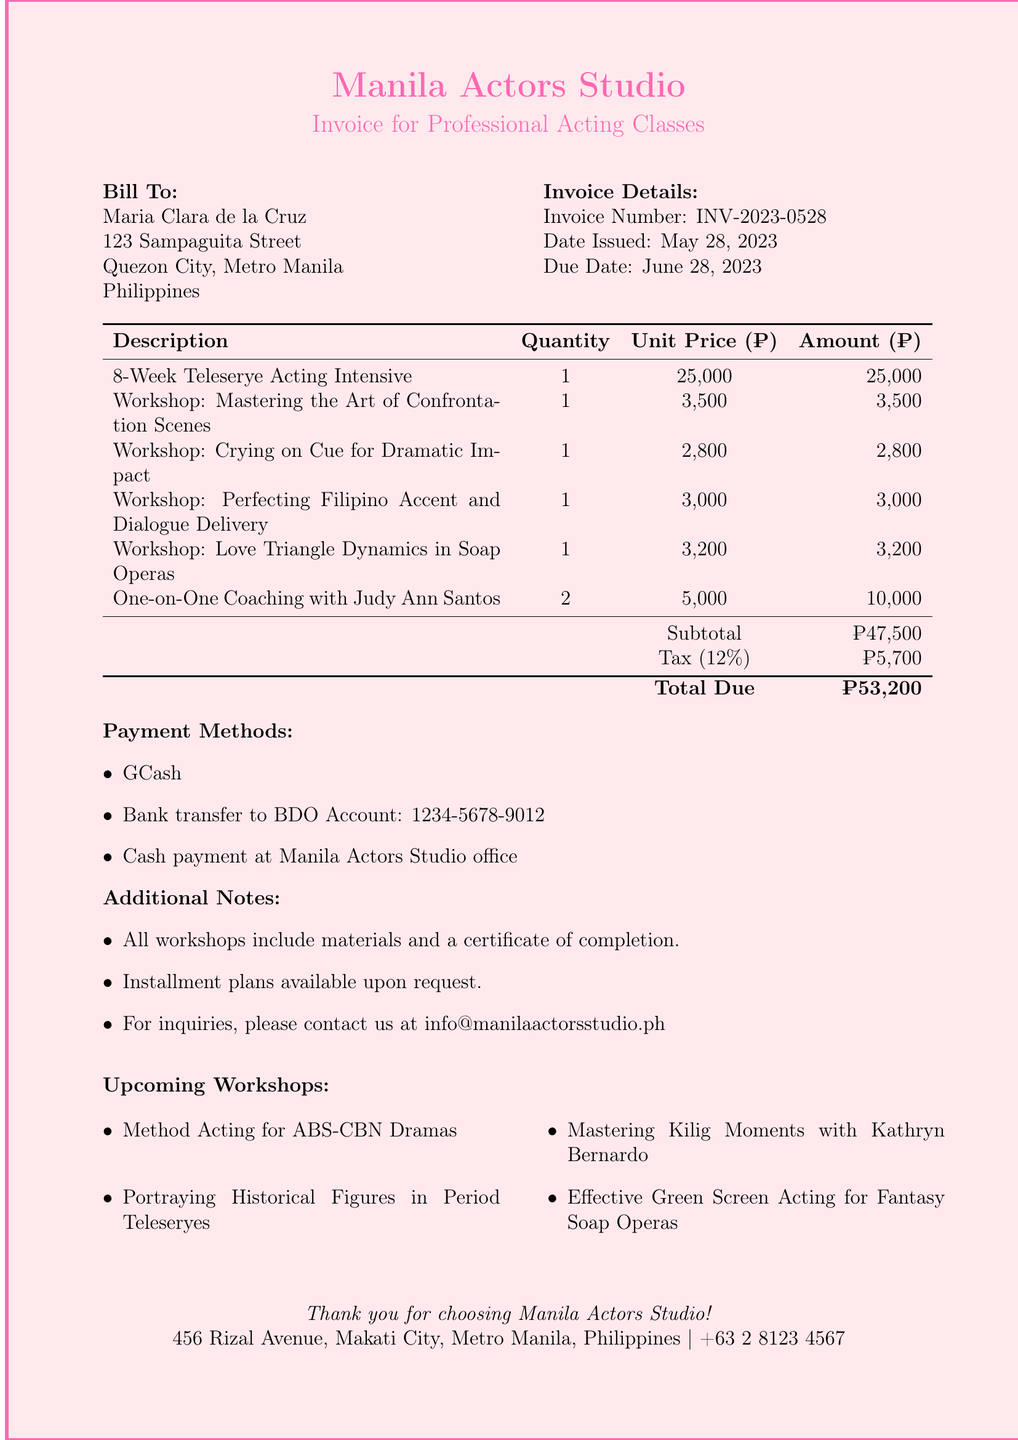What is the invoice number? The invoice number is explicitly stated in the document under Invoice Details.
Answer: INV-2023-0528 What is the date issued? The date issued is mentioned in the document, which is part of the Invoice Details.
Answer: May 28, 2023 What is the total amount due? The total amount due is provided at the bottom of the itemized services table.
Answer: ₱53,200 What payment methods are listed? The payment methods are detailed in a specific section of the invoice.
Answer: GCash, Bank transfer to BDO Account: 1234-5678-9012, Cash payment at Manila Actors Studio office How many workshops are included in the invoice? The total number of workshops can be calculated by counting the items in the itemized services list.
Answer: 5 What workshop focuses on confrontation scenes? This information is found under the itemized services provided in the document.
Answer: Mastering the Art of Confrontation Scenes What is the tax rate applied to the invoice? The tax rate is mentioned in the subtotal and tax sections of the document.
Answer: 12% How many one-on-one coaching sessions are included? The quantity of one-on-one coaching sessions is specified in the itemized services table.
Answer: 2 Which workshop is aimed at perfecting Filipino accent? This workshop is stated in the list of itemized services in the invoice.
Answer: Perfecting Filipino Accent and Dialogue Delivery 